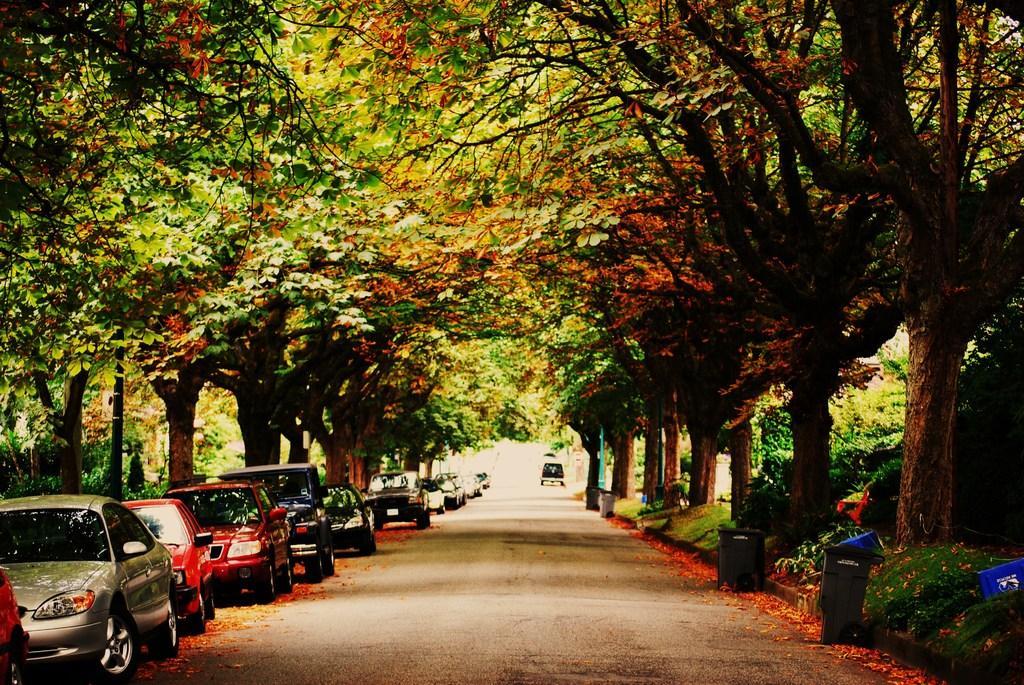Could you give a brief overview of what you see in this image? In this image we can see a few vehicles, dustbins, grass, plants and trees. 